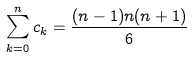Convert formula to latex. <formula><loc_0><loc_0><loc_500><loc_500>\sum _ { k = 0 } ^ { n } c _ { k } = \frac { ( n - 1 ) n ( n + 1 ) } { 6 }</formula> 